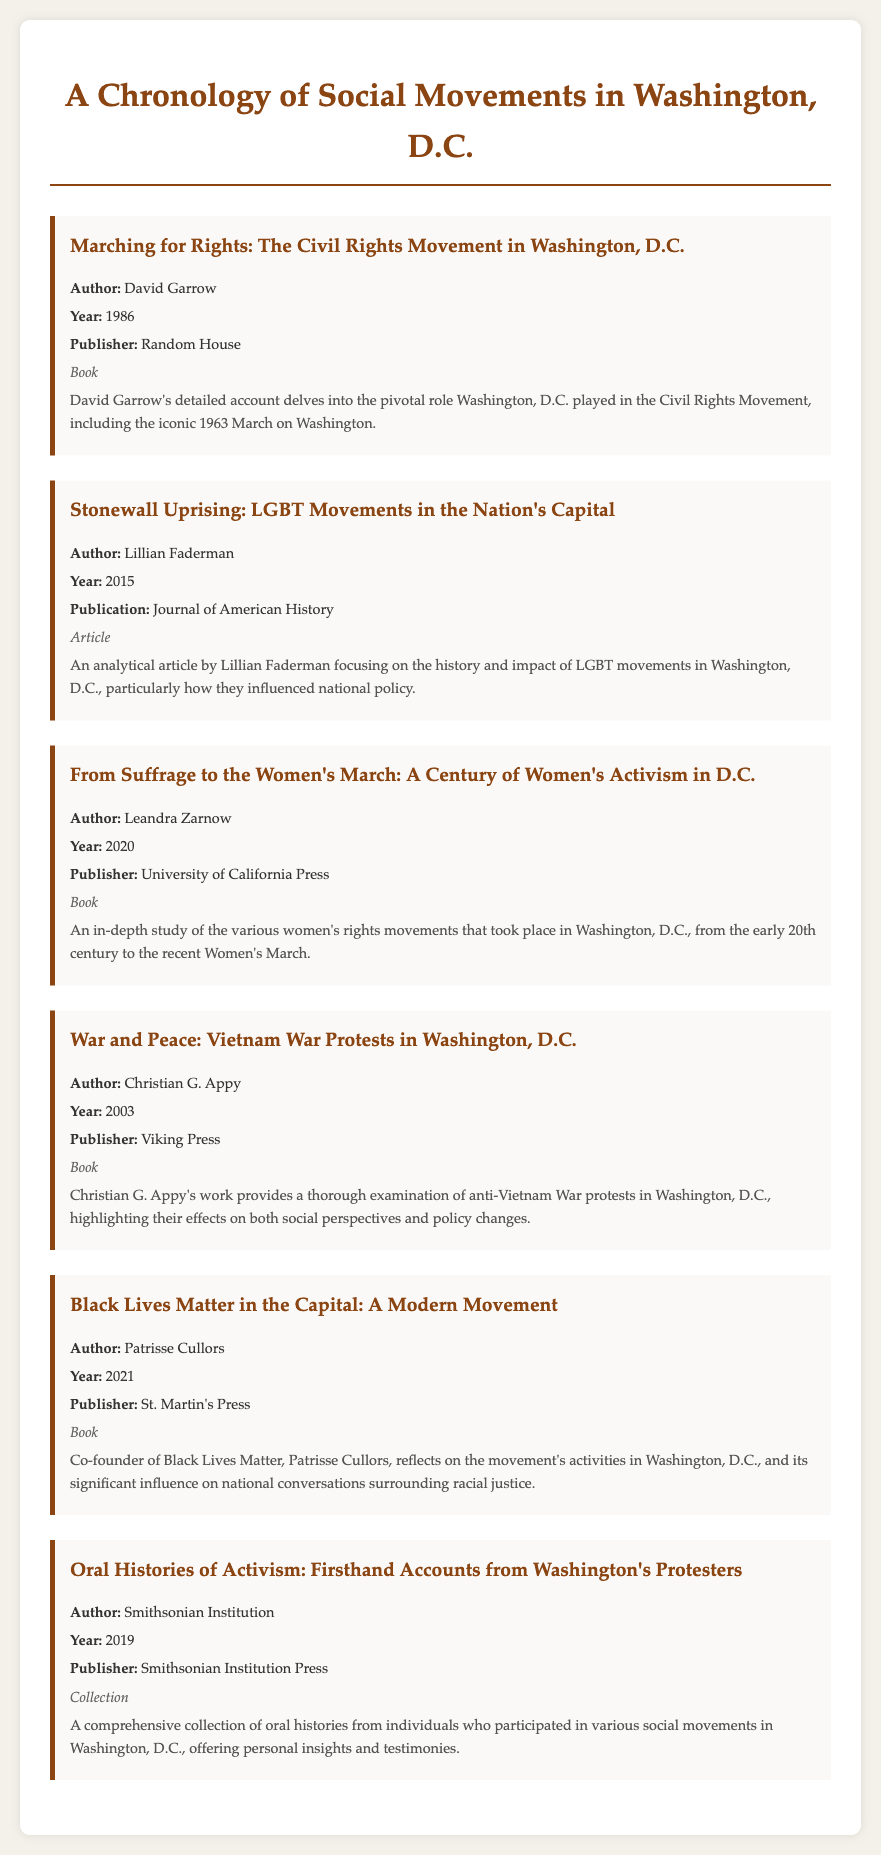What is the title of the first entry? The title of the first entry is "Marching for Rights: The Civil Rights Movement in Washington, D.C."
Answer: Marching for Rights: The Civil Rights Movement in Washington, D.C Who is the author of the book published in 2020? The author of the book published in 2020 is Leandra Zarnow.
Answer: Leandra Zarnow In what year was the article by Lillian Faderman published? The article by Lillian Faderman was published in 2015.
Answer: 2015 Which social movement does Patrisse Cullors discuss in her entry? Patrisse Cullors discusses the Black Lives Matter movement in her entry.
Answer: Black Lives Matter How many entries are listed in the bibliography? There are a total of six entries listed in the bibliography.
Answer: Six What type of publication is the entry about oral histories? The entry about oral histories is a collection.
Answer: Collection Which publisher released the work of Christian G. Appy? The publisher that released the work of Christian G. Appy is Viking Press.
Answer: Viking Press What major event is associated with the book by David Garrow? The major event associated with the book by David Garrow is the 1963 March on Washington.
Answer: 1963 March on Washington 